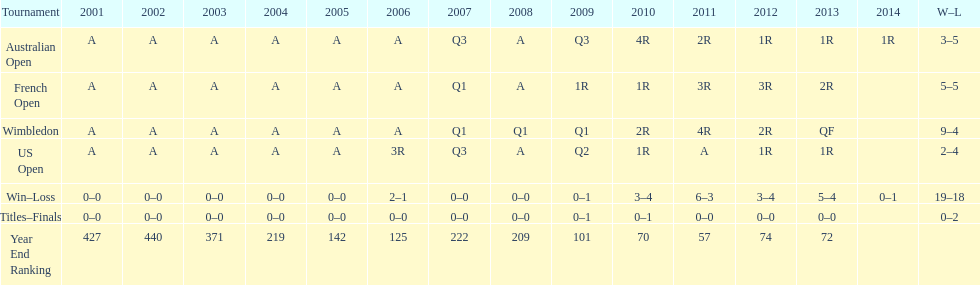What was the complete sum of games conducted between 2001 and 2014? 37. 